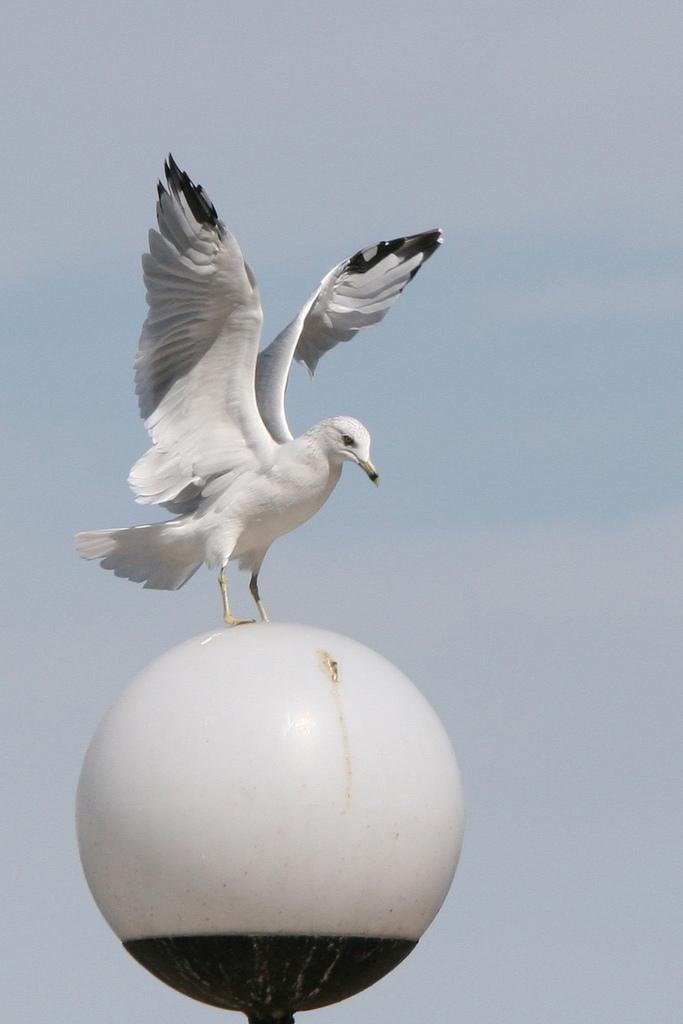What type of animal can be seen in the image? There is a bird in the image. Where is the bird located? The bird is on a street light. What can be seen in the background of the image? There is sky visible in the background of the image. What type of wood is the bird using to build its nest in the image? There is no nest visible in the image, and the bird is not using any wood to build one. 